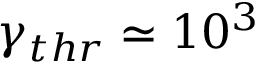<formula> <loc_0><loc_0><loc_500><loc_500>\gamma _ { t h r } \simeq 1 0 ^ { 3 }</formula> 